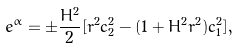<formula> <loc_0><loc_0><loc_500><loc_500>e ^ { \alpha } = \pm \frac { H ^ { 2 } } { 2 } [ r ^ { 2 } c _ { 2 } ^ { 2 } - ( 1 + H ^ { 2 } r ^ { 2 } ) c _ { 1 } ^ { 2 } ] ,</formula> 